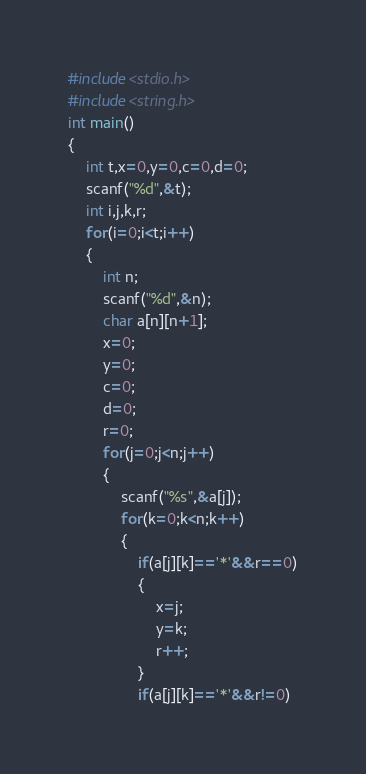Convert code to text. <code><loc_0><loc_0><loc_500><loc_500><_C_>#include<stdio.h>
#include<string.h>
int main()
{
    int t,x=0,y=0,c=0,d=0;
    scanf("%d",&t);
    int i,j,k,r;
    for(i=0;i<t;i++)
    {
        int n;
        scanf("%d",&n);
        char a[n][n+1];
        x=0;
        y=0;
        c=0;
        d=0;
        r=0;
        for(j=0;j<n;j++)
        {
            scanf("%s",&a[j]);
            for(k=0;k<n;k++)
            {
                if(a[j][k]=='*'&&r==0)
                {
                    x=j;
                    y=k;
                    r++;
                }
                if(a[j][k]=='*'&&r!=0)</code> 